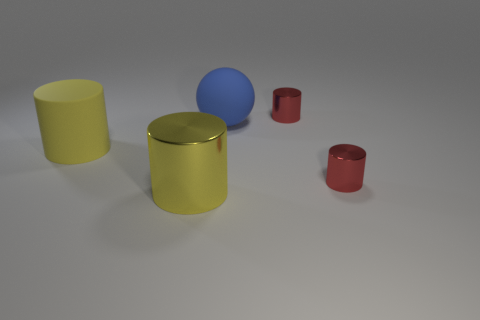Add 4 large metal things. How many objects exist? 9 Subtract all yellow rubber cylinders. How many cylinders are left? 3 Subtract all cylinders. How many objects are left? 1 Subtract 3 cylinders. How many cylinders are left? 1 Subtract 0 cyan spheres. How many objects are left? 5 Subtract all gray cylinders. Subtract all cyan cubes. How many cylinders are left? 4 Subtract all yellow cylinders. How many cyan spheres are left? 0 Subtract all brown cylinders. Subtract all red things. How many objects are left? 3 Add 2 spheres. How many spheres are left? 3 Add 5 rubber balls. How many rubber balls exist? 6 